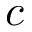<formula> <loc_0><loc_0><loc_500><loc_500>c</formula> 